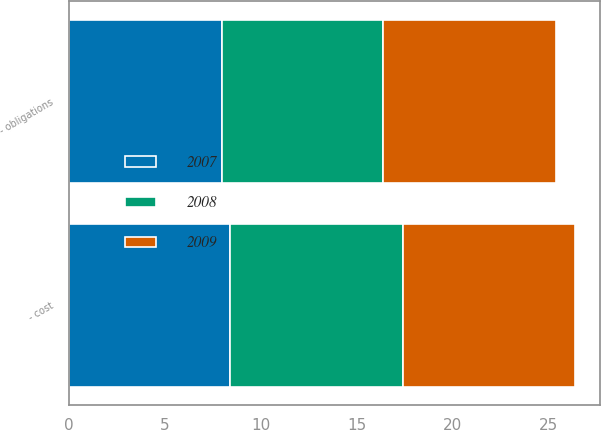<chart> <loc_0><loc_0><loc_500><loc_500><stacked_bar_chart><ecel><fcel>- obligations<fcel>- cost<nl><fcel>2007<fcel>8<fcel>8.4<nl><fcel>2008<fcel>8.4<fcel>9<nl><fcel>2009<fcel>9<fcel>9<nl></chart> 